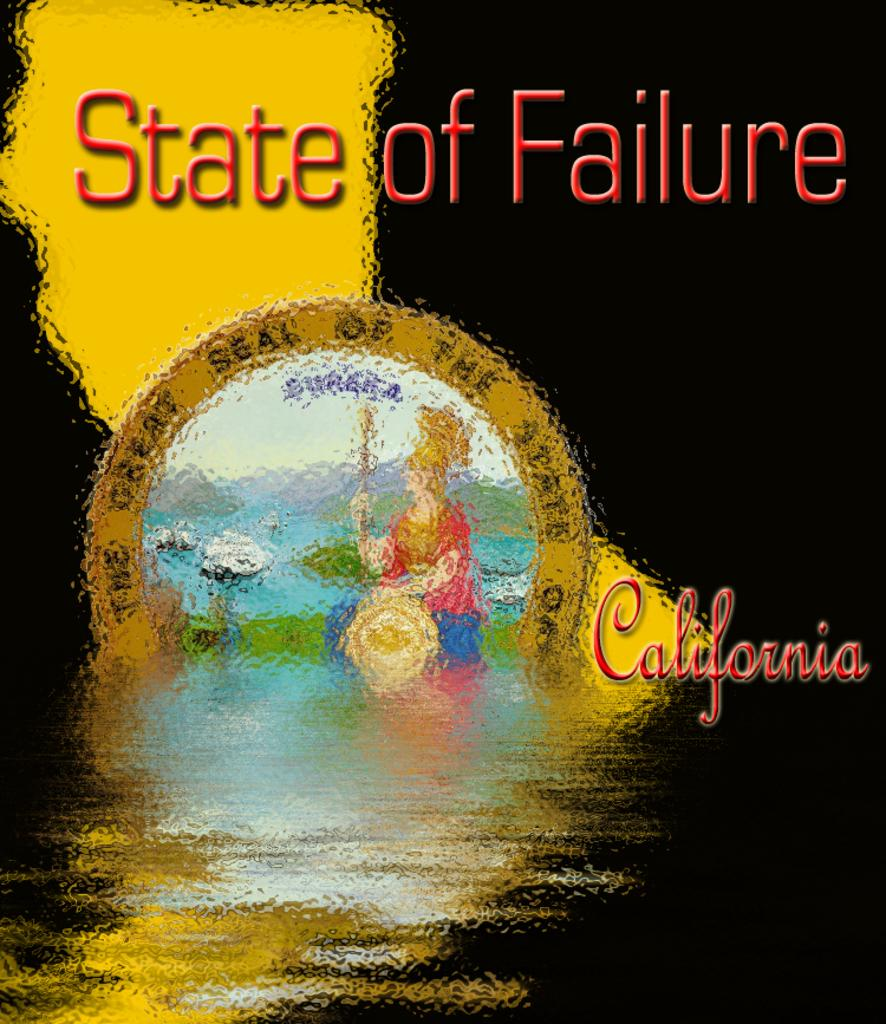<image>
Render a clear and concise summary of the photo. The cover of State of Failure with a lady and some flowers. 